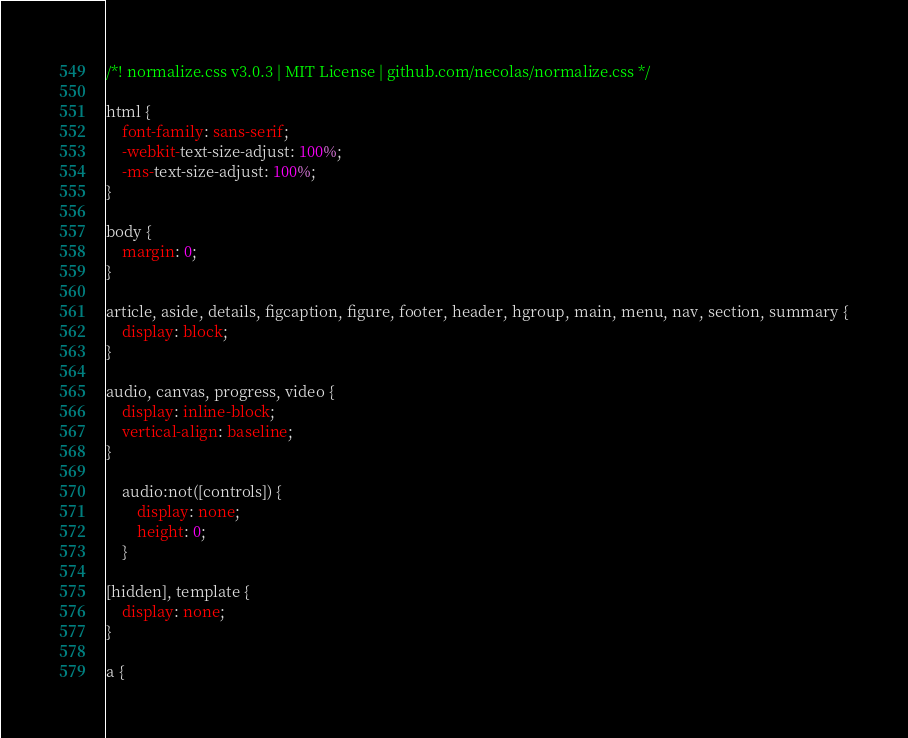Convert code to text. <code><loc_0><loc_0><loc_500><loc_500><_CSS_>/*! normalize.css v3.0.3 | MIT License | github.com/necolas/normalize.css */

html {
    font-family: sans-serif;
    -webkit-text-size-adjust: 100%;
    -ms-text-size-adjust: 100%;
}

body {
    margin: 0;
}

article, aside, details, figcaption, figure, footer, header, hgroup, main, menu, nav, section, summary {
    display: block;
}

audio, canvas, progress, video {
    display: inline-block;
    vertical-align: baseline;
}

    audio:not([controls]) {
        display: none;
        height: 0;
    }

[hidden], template {
    display: none;
}

a {</code> 